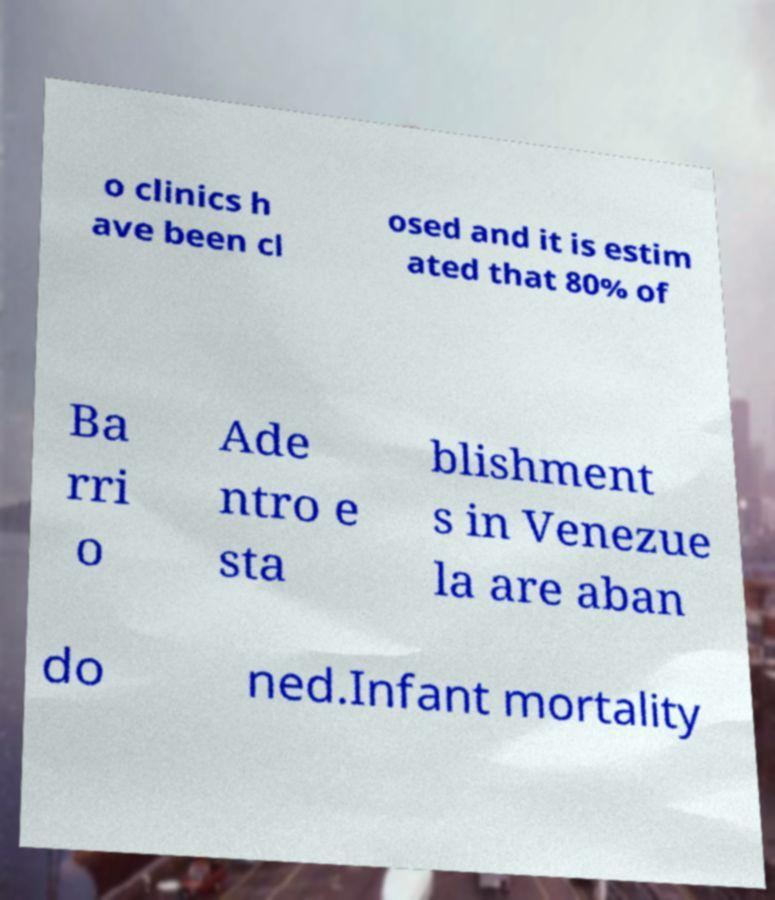Can you read and provide the text displayed in the image?This photo seems to have some interesting text. Can you extract and type it out for me? o clinics h ave been cl osed and it is estim ated that 80% of Ba rri o Ade ntro e sta blishment s in Venezue la are aban do ned.Infant mortality 